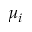<formula> <loc_0><loc_0><loc_500><loc_500>\mu _ { i }</formula> 